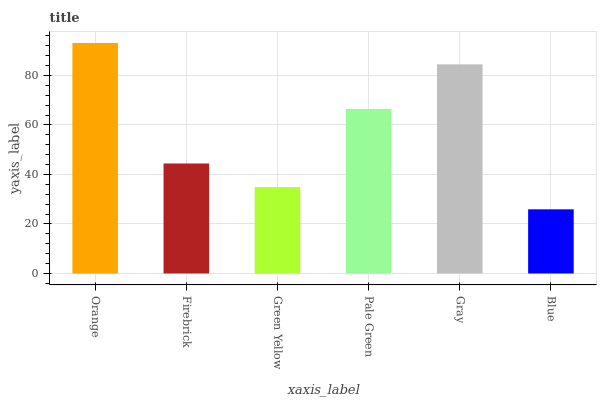Is Blue the minimum?
Answer yes or no. Yes. Is Orange the maximum?
Answer yes or no. Yes. Is Firebrick the minimum?
Answer yes or no. No. Is Firebrick the maximum?
Answer yes or no. No. Is Orange greater than Firebrick?
Answer yes or no. Yes. Is Firebrick less than Orange?
Answer yes or no. Yes. Is Firebrick greater than Orange?
Answer yes or no. No. Is Orange less than Firebrick?
Answer yes or no. No. Is Pale Green the high median?
Answer yes or no. Yes. Is Firebrick the low median?
Answer yes or no. Yes. Is Blue the high median?
Answer yes or no. No. Is Green Yellow the low median?
Answer yes or no. No. 